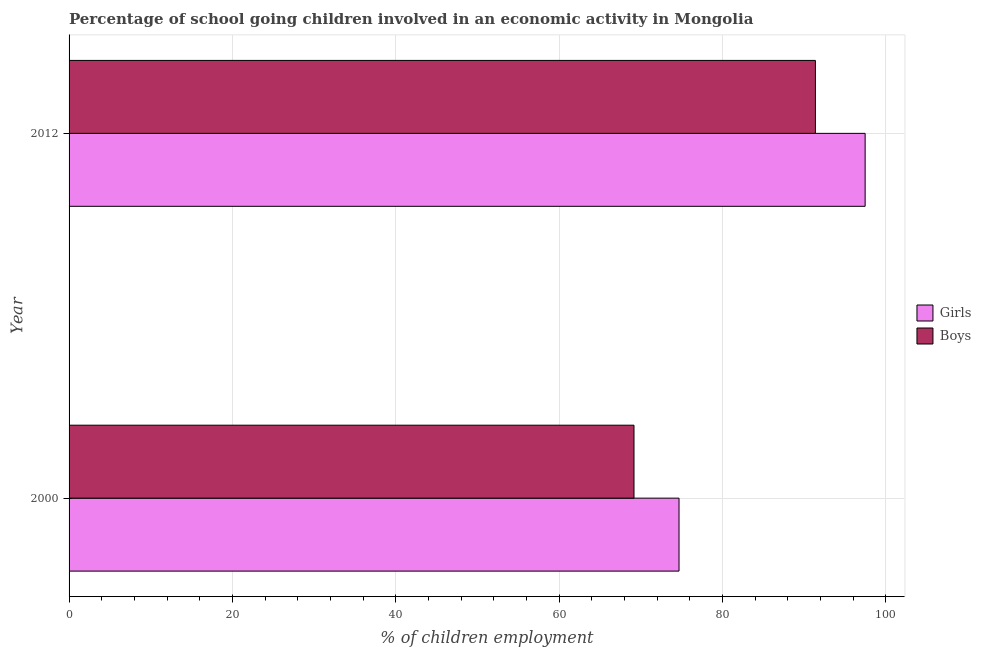How many groups of bars are there?
Ensure brevity in your answer.  2. Are the number of bars per tick equal to the number of legend labels?
Offer a terse response. Yes. Are the number of bars on each tick of the Y-axis equal?
Provide a short and direct response. Yes. How many bars are there on the 2nd tick from the top?
Offer a terse response. 2. How many bars are there on the 1st tick from the bottom?
Your answer should be very brief. 2. What is the percentage of school going boys in 2012?
Provide a succinct answer. 91.38. Across all years, what is the maximum percentage of school going girls?
Keep it short and to the point. 97.47. Across all years, what is the minimum percentage of school going girls?
Keep it short and to the point. 74.68. In which year was the percentage of school going girls maximum?
Provide a succinct answer. 2012. What is the total percentage of school going girls in the graph?
Keep it short and to the point. 172.15. What is the difference between the percentage of school going boys in 2000 and that in 2012?
Offer a terse response. -22.21. What is the difference between the percentage of school going boys in 2000 and the percentage of school going girls in 2012?
Provide a short and direct response. -28.3. What is the average percentage of school going boys per year?
Offer a very short reply. 80.27. In the year 2012, what is the difference between the percentage of school going girls and percentage of school going boys?
Your answer should be very brief. 6.09. In how many years, is the percentage of school going boys greater than 92 %?
Your answer should be very brief. 0. What is the ratio of the percentage of school going girls in 2000 to that in 2012?
Keep it short and to the point. 0.77. What does the 2nd bar from the top in 2012 represents?
Offer a very short reply. Girls. What does the 2nd bar from the bottom in 2012 represents?
Your answer should be compact. Boys. How many bars are there?
Provide a succinct answer. 4. Does the graph contain grids?
Offer a terse response. Yes. How are the legend labels stacked?
Keep it short and to the point. Vertical. What is the title of the graph?
Your response must be concise. Percentage of school going children involved in an economic activity in Mongolia. Does "Domestic liabilities" appear as one of the legend labels in the graph?
Your answer should be compact. No. What is the label or title of the X-axis?
Give a very brief answer. % of children employment. What is the % of children employment in Girls in 2000?
Ensure brevity in your answer.  74.68. What is the % of children employment in Boys in 2000?
Your answer should be very brief. 69.17. What is the % of children employment in Girls in 2012?
Provide a succinct answer. 97.47. What is the % of children employment of Boys in 2012?
Keep it short and to the point. 91.38. Across all years, what is the maximum % of children employment in Girls?
Offer a terse response. 97.47. Across all years, what is the maximum % of children employment of Boys?
Ensure brevity in your answer.  91.38. Across all years, what is the minimum % of children employment of Girls?
Offer a terse response. 74.68. Across all years, what is the minimum % of children employment in Boys?
Your answer should be compact. 69.17. What is the total % of children employment of Girls in the graph?
Offer a very short reply. 172.15. What is the total % of children employment in Boys in the graph?
Your response must be concise. 160.55. What is the difference between the % of children employment of Girls in 2000 and that in 2012?
Make the answer very short. -22.79. What is the difference between the % of children employment in Boys in 2000 and that in 2012?
Keep it short and to the point. -22.21. What is the difference between the % of children employment of Girls in 2000 and the % of children employment of Boys in 2012?
Offer a very short reply. -16.7. What is the average % of children employment in Girls per year?
Make the answer very short. 86.08. What is the average % of children employment of Boys per year?
Ensure brevity in your answer.  80.27. In the year 2000, what is the difference between the % of children employment in Girls and % of children employment in Boys?
Offer a terse response. 5.51. In the year 2012, what is the difference between the % of children employment in Girls and % of children employment in Boys?
Provide a succinct answer. 6.09. What is the ratio of the % of children employment in Girls in 2000 to that in 2012?
Give a very brief answer. 0.77. What is the ratio of the % of children employment of Boys in 2000 to that in 2012?
Offer a terse response. 0.76. What is the difference between the highest and the second highest % of children employment in Girls?
Offer a very short reply. 22.79. What is the difference between the highest and the second highest % of children employment of Boys?
Offer a terse response. 22.21. What is the difference between the highest and the lowest % of children employment in Girls?
Your answer should be very brief. 22.79. What is the difference between the highest and the lowest % of children employment in Boys?
Make the answer very short. 22.21. 